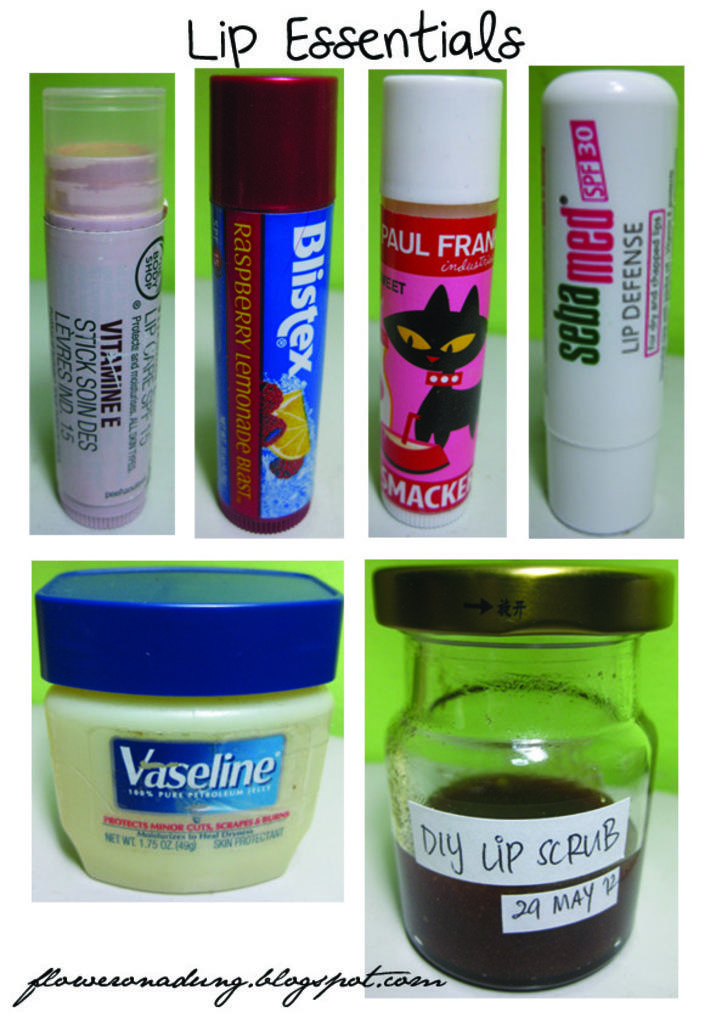What kind of essentials are these for?
Keep it short and to the point. Lip. 